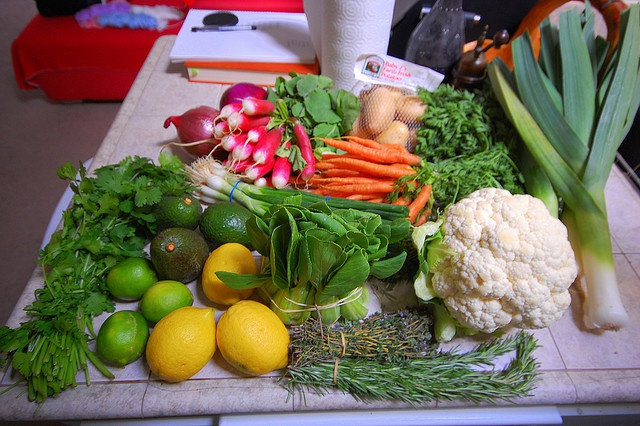Describe the objects in this image and their specific colors. I can see broccoli in purple, lightgray, darkgray, tan, and olive tones, book in purple, lavender, gray, and darkgray tones, carrot in purple, red, salmon, and brown tones, orange in purple, gold, and olive tones, and bottle in purple and black tones in this image. 